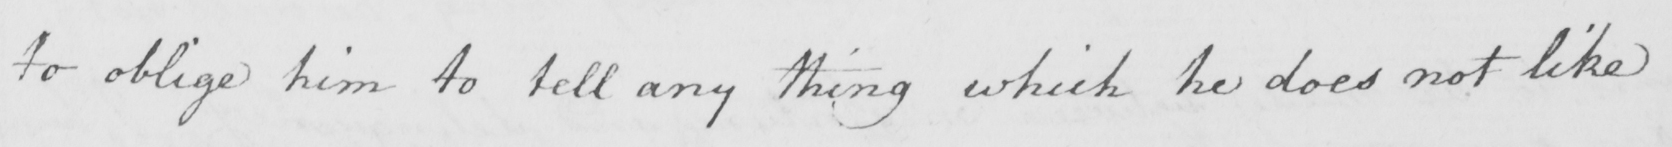Transcribe the text shown in this historical manuscript line. to oblige him to tell any thing which he does not like 